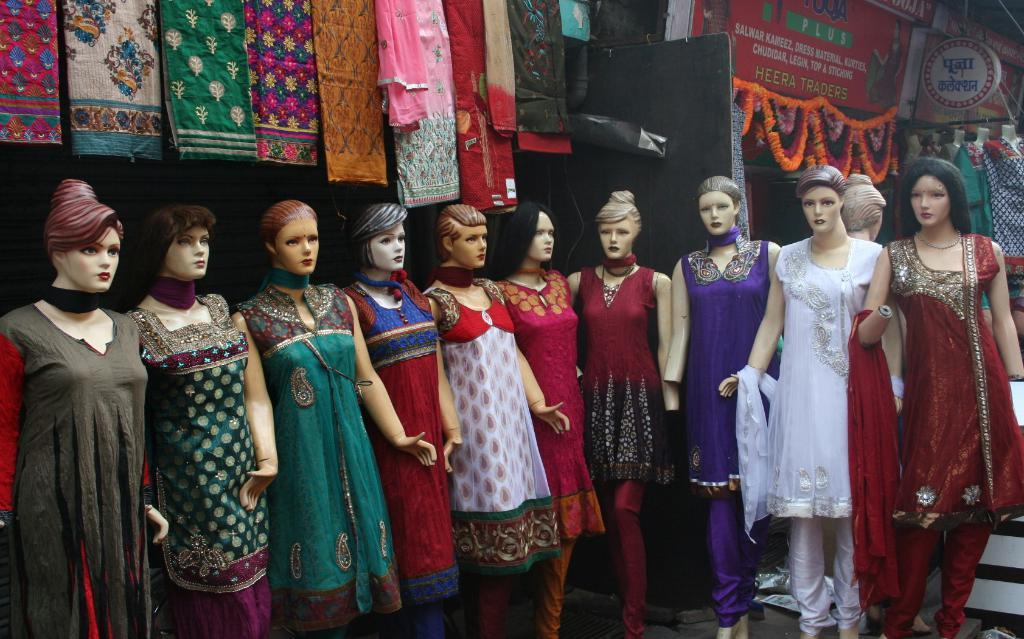What type of toys can be seen in the image? There are women's toys in the image. What type of clothing is visible in the image? There are dresses and other clothes present in the image. What architectural feature can be seen in the image? There is a door in the image. What decorative item is visible in the image? A garland is visible in the image. What type of advertisement is present in the image? There is a hoarding in the image. Can you describe any other objects in the image? There are other objects in the image, but their specific details are not mentioned in the provided facts. How many sheep are in the flock visible in the image? There is no flock of sheep present in the image. What type of grape is being used to decorate the dresses in the image? There is no grape used to decorate the dresses in the image. 